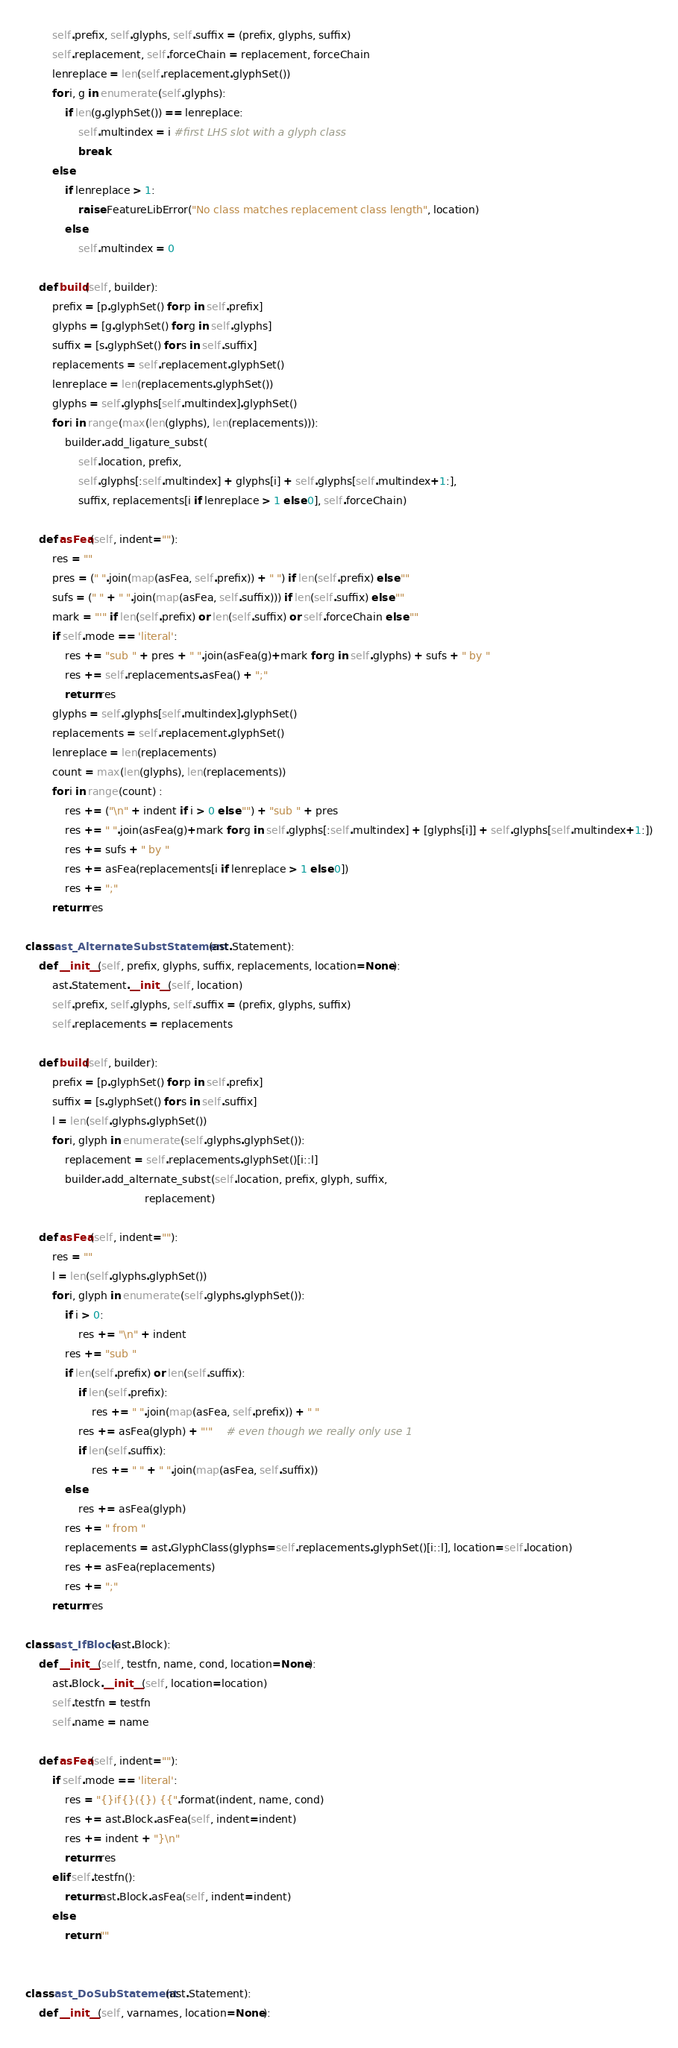<code> <loc_0><loc_0><loc_500><loc_500><_Python_>        self.prefix, self.glyphs, self.suffix = (prefix, glyphs, suffix)
        self.replacement, self.forceChain = replacement, forceChain
        lenreplace = len(self.replacement.glyphSet())
        for i, g in enumerate(self.glyphs):
            if len(g.glyphSet()) == lenreplace:
                self.multindex = i #first LHS slot with a glyph class
                break
        else:
            if lenreplace > 1:
                raise FeatureLibError("No class matches replacement class length", location)
            else:
                self.multindex = 0

    def build(self, builder):
        prefix = [p.glyphSet() for p in self.prefix]
        glyphs = [g.glyphSet() for g in self.glyphs]
        suffix = [s.glyphSet() for s in self.suffix]
        replacements = self.replacement.glyphSet()
        lenreplace = len(replacements.glyphSet())
        glyphs = self.glyphs[self.multindex].glyphSet()
        for i in range(max(len(glyphs), len(replacements))):
            builder.add_ligature_subst(
                self.location, prefix,
                self.glyphs[:self.multindex] + glyphs[i] + self.glyphs[self.multindex+1:],
                suffix, replacements[i if lenreplace > 1 else 0], self.forceChain)

    def asFea(self, indent=""):
        res = ""
        pres = (" ".join(map(asFea, self.prefix)) + " ") if len(self.prefix) else ""
        sufs = (" " + " ".join(map(asFea, self.suffix))) if len(self.suffix) else ""
        mark = "'" if len(self.prefix) or len(self.suffix) or self.forceChain else ""
        if self.mode == 'literal':
            res += "sub " + pres + " ".join(asFea(g)+mark for g in self.glyphs) + sufs + " by "
            res += self.replacements.asFea() + ";"
            return res
        glyphs = self.glyphs[self.multindex].glyphSet()
        replacements = self.replacement.glyphSet()
        lenreplace = len(replacements)
        count = max(len(glyphs), len(replacements))
        for i in range(count) :
            res += ("\n" + indent if i > 0 else "") + "sub " + pres
            res += " ".join(asFea(g)+mark for g in self.glyphs[:self.multindex] + [glyphs[i]] + self.glyphs[self.multindex+1:])
            res += sufs + " by "
            res += asFea(replacements[i if lenreplace > 1 else 0])
            res += ";"
        return res

class ast_AlternateSubstStatement(ast.Statement):
    def __init__(self, prefix, glyphs, suffix, replacements, location=None):
        ast.Statement.__init__(self, location)
        self.prefix, self.glyphs, self.suffix = (prefix, glyphs, suffix)
        self.replacements = replacements

    def build(self, builder):
        prefix = [p.glyphSet() for p in self.prefix]
        suffix = [s.glyphSet() for s in self.suffix]
        l = len(self.glyphs.glyphSet())
        for i, glyph in enumerate(self.glyphs.glyphSet()):
            replacement = self.replacements.glyphSet()[i::l]
            builder.add_alternate_subst(self.location, prefix, glyph, suffix,
                                    replacement)

    def asFea(self, indent=""):
        res = ""
        l = len(self.glyphs.glyphSet())
        for i, glyph in enumerate(self.glyphs.glyphSet()):
            if i > 0:
                res += "\n" + indent
            res += "sub "
            if len(self.prefix) or len(self.suffix):
                if len(self.prefix):
                    res += " ".join(map(asFea, self.prefix)) + " "
                res += asFea(glyph) + "'"    # even though we really only use 1
                if len(self.suffix):
                    res += " " + " ".join(map(asFea, self.suffix))
            else:
                res += asFea(glyph)
            res += " from "
            replacements = ast.GlyphClass(glyphs=self.replacements.glyphSet()[i::l], location=self.location)
            res += asFea(replacements)
            res += ";"
        return res

class ast_IfBlock(ast.Block):
    def __init__(self, testfn, name, cond, location=None):
        ast.Block.__init__(self, location=location)
        self.testfn = testfn
        self.name = name

    def asFea(self, indent=""):
        if self.mode == 'literal':
            res = "{}if{}({}) {{".format(indent, name, cond)
            res += ast.Block.asFea(self, indent=indent)
            res += indent + "}\n"
            return res
        elif self.testfn():
            return ast.Block.asFea(self, indent=indent)
        else:
            return ""


class ast_DoSubStatement(ast.Statement):
    def __init__(self, varnames, location=None):</code> 